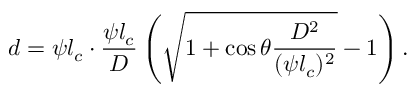Convert formula to latex. <formula><loc_0><loc_0><loc_500><loc_500>d = \psi l _ { c } \cdot \frac { \psi l _ { c } } { D } \left ( \sqrt { 1 + { \cos \theta } \frac { D ^ { 2 } } { ( \psi l _ { c } ) ^ { 2 } } } - 1 \right ) .</formula> 